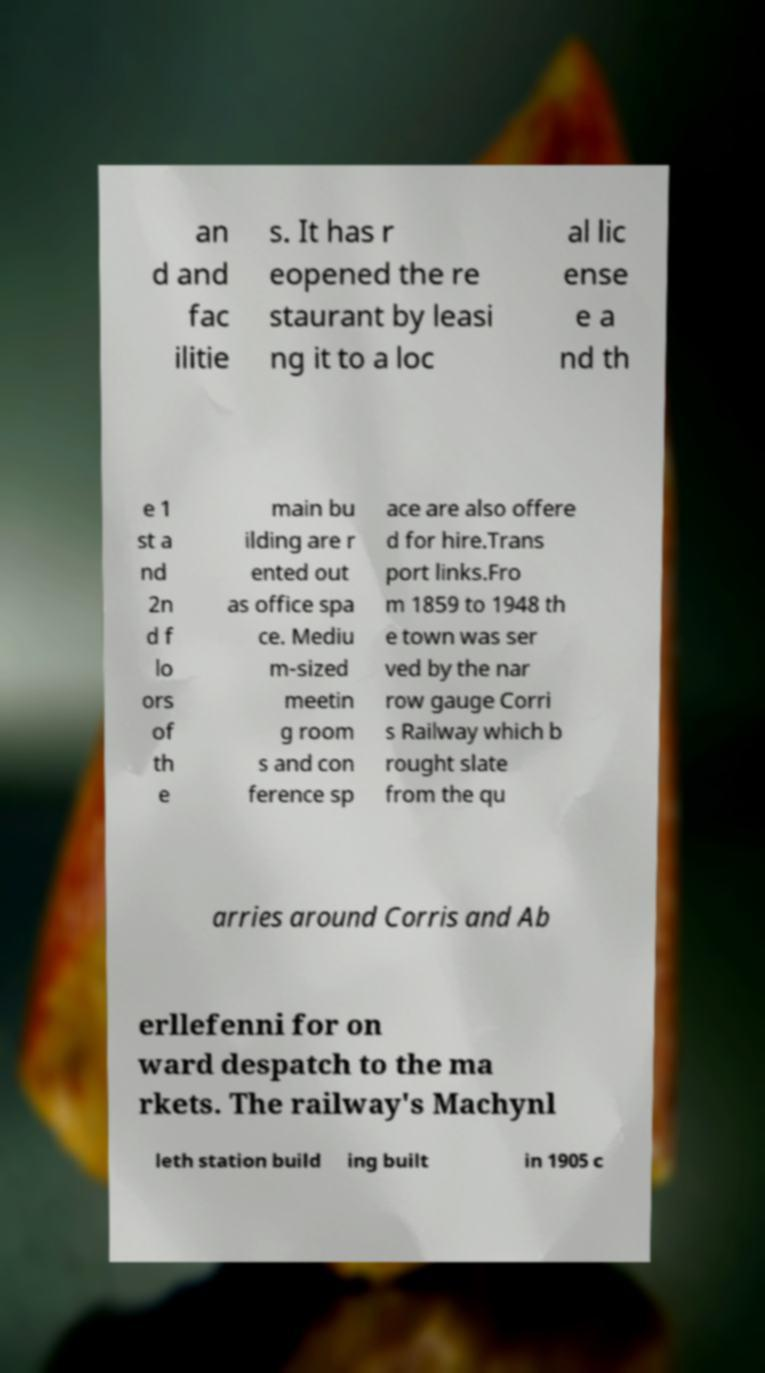Could you assist in decoding the text presented in this image and type it out clearly? an d and fac ilitie s. It has r eopened the re staurant by leasi ng it to a loc al lic ense e a nd th e 1 st a nd 2n d f lo ors of th e main bu ilding are r ented out as office spa ce. Mediu m-sized meetin g room s and con ference sp ace are also offere d for hire.Trans port links.Fro m 1859 to 1948 th e town was ser ved by the nar row gauge Corri s Railway which b rought slate from the qu arries around Corris and Ab erllefenni for on ward despatch to the ma rkets. The railway's Machynl leth station build ing built in 1905 c 